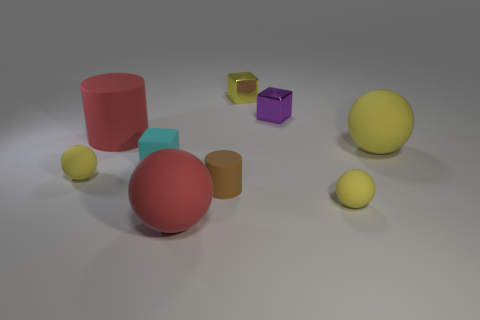Is the shape of the big red object that is behind the large yellow rubber thing the same as the large matte thing that is right of the big red sphere?
Offer a terse response. No. What number of large green shiny cylinders are there?
Your response must be concise. 0. There is a matte block that is the same size as the brown rubber thing; what color is it?
Your answer should be compact. Cyan. Are the big red object that is behind the tiny brown rubber thing and the big red object that is right of the matte cube made of the same material?
Ensure brevity in your answer.  Yes. There is a yellow sphere in front of the yellow rubber thing left of the purple thing; what size is it?
Make the answer very short. Small. What is the small ball that is to the left of the big rubber cylinder made of?
Keep it short and to the point. Rubber. What number of objects are rubber balls that are to the right of the small brown cylinder or big rubber balls that are to the right of the red ball?
Keep it short and to the point. 2. There is a tiny cyan thing that is the same shape as the purple metal object; what is its material?
Make the answer very short. Rubber. Does the small rubber object that is right of the tiny yellow metallic cube have the same color as the small shiny block in front of the tiny yellow metallic block?
Offer a very short reply. No. Is there a yellow rubber thing of the same size as the red rubber sphere?
Provide a short and direct response. Yes. 